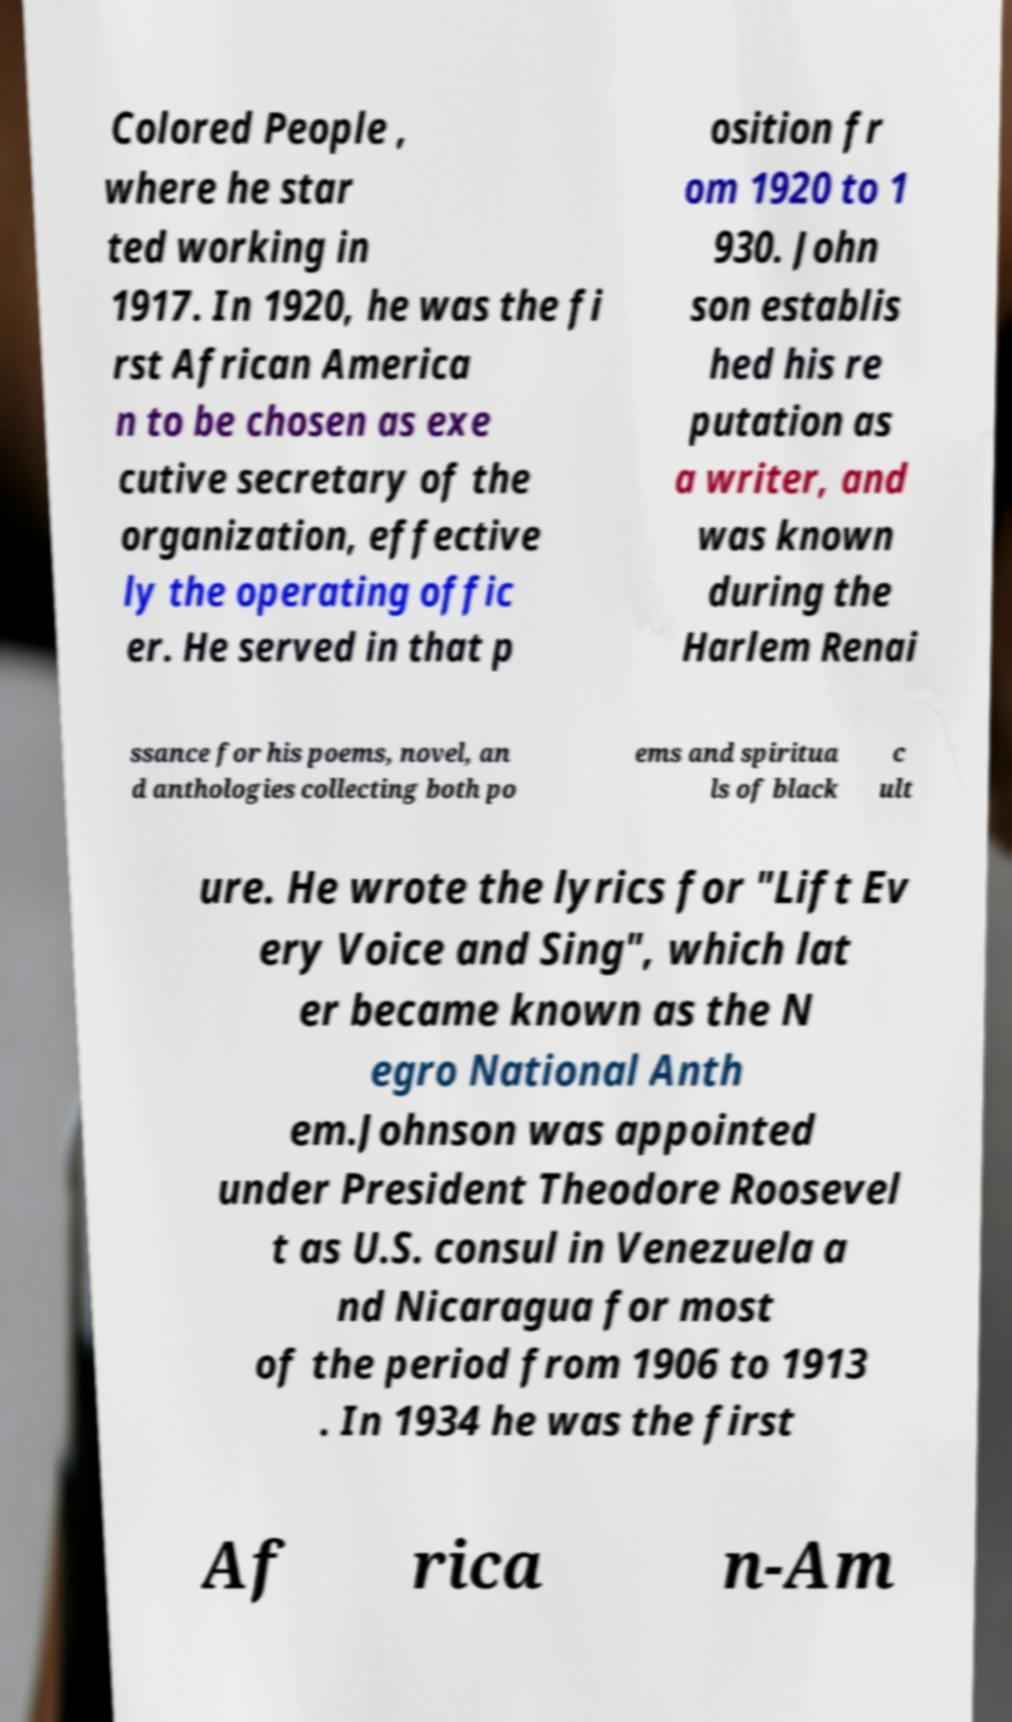Can you read and provide the text displayed in the image?This photo seems to have some interesting text. Can you extract and type it out for me? Colored People , where he star ted working in 1917. In 1920, he was the fi rst African America n to be chosen as exe cutive secretary of the organization, effective ly the operating offic er. He served in that p osition fr om 1920 to 1 930. John son establis hed his re putation as a writer, and was known during the Harlem Renai ssance for his poems, novel, an d anthologies collecting both po ems and spiritua ls of black c ult ure. He wrote the lyrics for "Lift Ev ery Voice and Sing", which lat er became known as the N egro National Anth em.Johnson was appointed under President Theodore Roosevel t as U.S. consul in Venezuela a nd Nicaragua for most of the period from 1906 to 1913 . In 1934 he was the first Af rica n-Am 